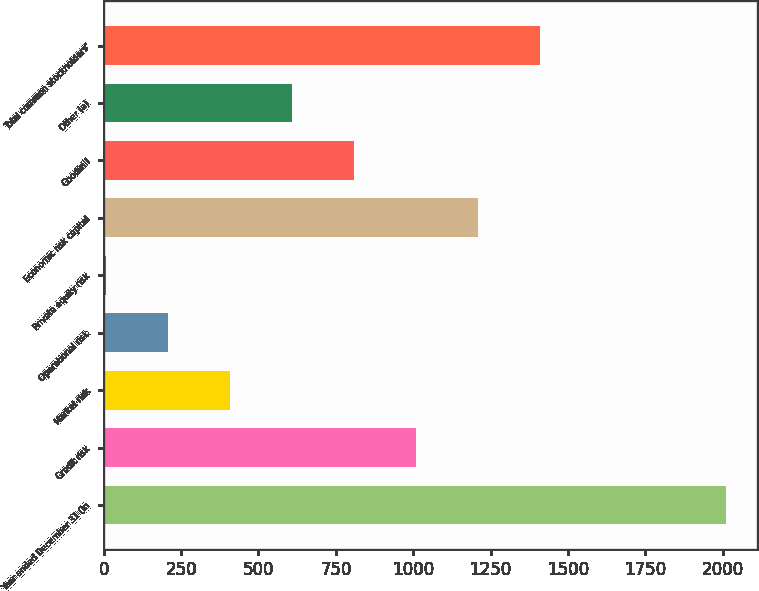Convert chart to OTSL. <chart><loc_0><loc_0><loc_500><loc_500><bar_chart><fcel>Year ended December 31 (in<fcel>Credit risk<fcel>Market risk<fcel>Operational risk<fcel>Private equity risk<fcel>Economic risk capital<fcel>Goodwill<fcel>Other (a)<fcel>Total common stockholders'<nl><fcel>2010<fcel>1008.1<fcel>406.96<fcel>206.58<fcel>6.2<fcel>1208.48<fcel>807.72<fcel>607.34<fcel>1408.86<nl></chart> 